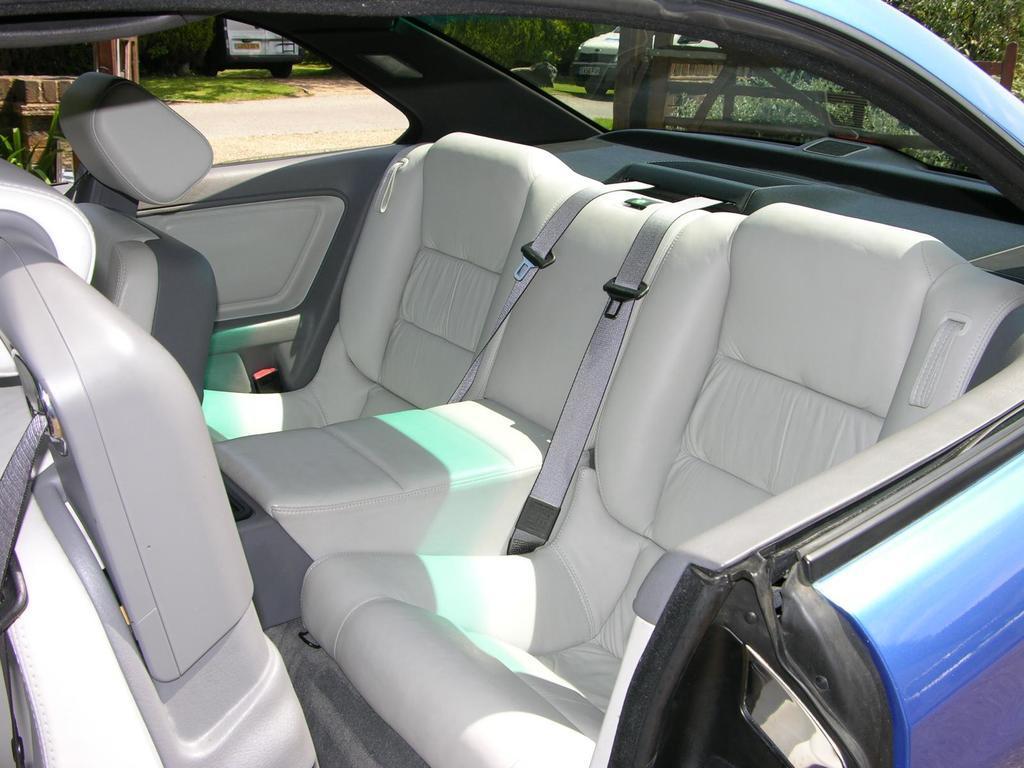How would you summarize this image in a sentence or two? In the image there is a car. Inside the car there are seats and also there are seat belts. And there are glasses. Behind the car there is fencing and a wall. And also there are trees and vehicles. 